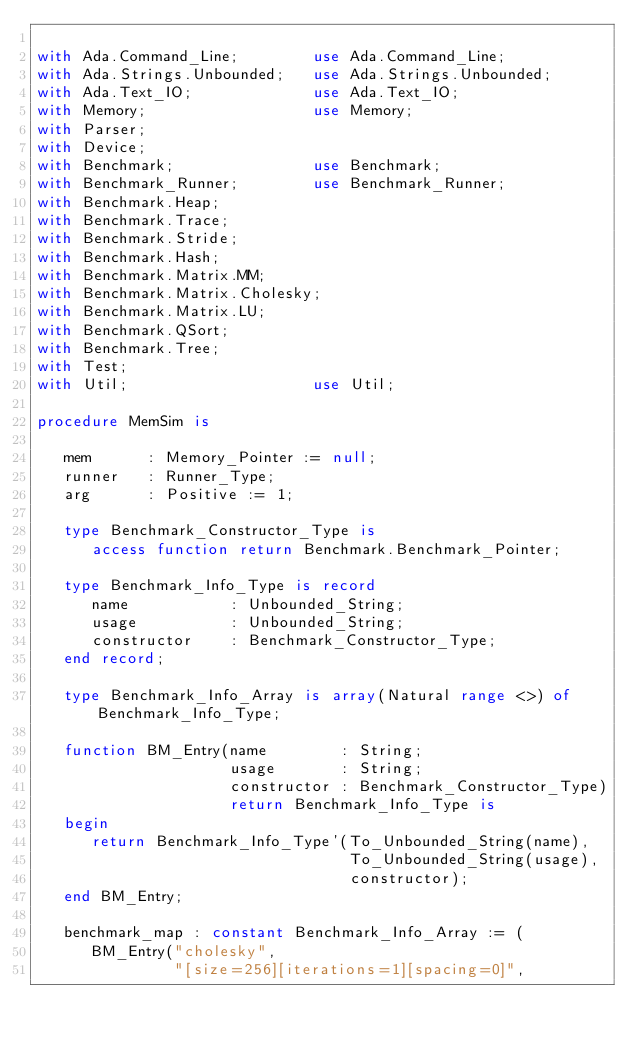Convert code to text. <code><loc_0><loc_0><loc_500><loc_500><_Ada_>
with Ada.Command_Line;        use Ada.Command_Line;
with Ada.Strings.Unbounded;   use Ada.Strings.Unbounded;
with Ada.Text_IO;             use Ada.Text_IO;
with Memory;                  use Memory;
with Parser;
with Device;
with Benchmark;               use Benchmark;
with Benchmark_Runner;        use Benchmark_Runner;
with Benchmark.Heap;
with Benchmark.Trace;
with Benchmark.Stride;
with Benchmark.Hash;
with Benchmark.Matrix.MM;
with Benchmark.Matrix.Cholesky;
with Benchmark.Matrix.LU;
with Benchmark.QSort;
with Benchmark.Tree;
with Test;
with Util;                    use Util;

procedure MemSim is

   mem      : Memory_Pointer := null;
   runner   : Runner_Type;
   arg      : Positive := 1;

   type Benchmark_Constructor_Type is
      access function return Benchmark.Benchmark_Pointer;

   type Benchmark_Info_Type is record
      name           : Unbounded_String;
      usage          : Unbounded_String;
      constructor    : Benchmark_Constructor_Type;
   end record;

   type Benchmark_Info_Array is array(Natural range <>) of Benchmark_Info_Type;

   function BM_Entry(name        : String;
                     usage       : String;
                     constructor : Benchmark_Constructor_Type)
                     return Benchmark_Info_Type is
   begin
      return Benchmark_Info_Type'(To_Unbounded_String(name),
                                  To_Unbounded_String(usage),
                                  constructor);
   end BM_Entry;

   benchmark_map : constant Benchmark_Info_Array := (
      BM_Entry("cholesky",
               "[size=256][iterations=1][spacing=0]",</code> 